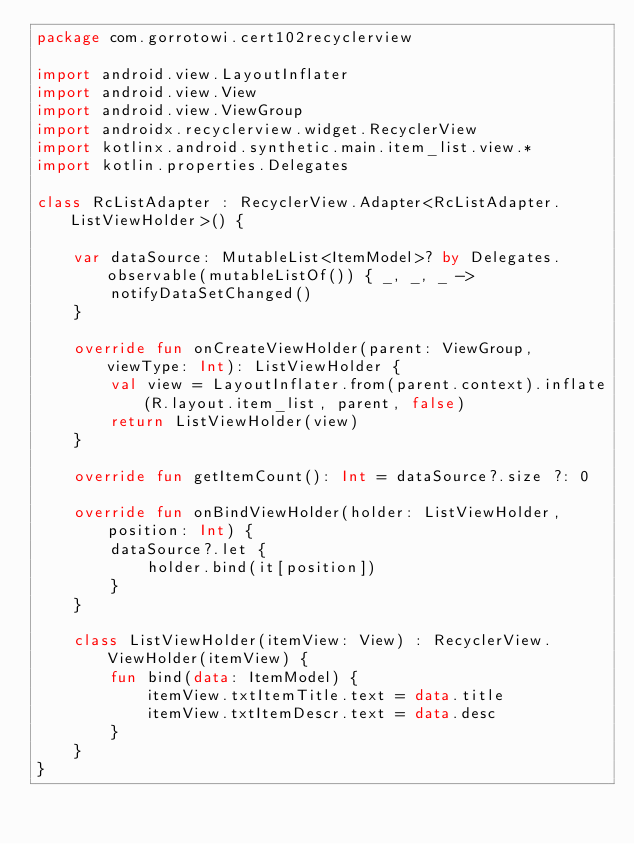Convert code to text. <code><loc_0><loc_0><loc_500><loc_500><_Kotlin_>package com.gorrotowi.cert102recyclerview

import android.view.LayoutInflater
import android.view.View
import android.view.ViewGroup
import androidx.recyclerview.widget.RecyclerView
import kotlinx.android.synthetic.main.item_list.view.*
import kotlin.properties.Delegates

class RcListAdapter : RecyclerView.Adapter<RcListAdapter.ListViewHolder>() {

    var dataSource: MutableList<ItemModel>? by Delegates.observable(mutableListOf()) { _, _, _ ->
        notifyDataSetChanged()
    }

    override fun onCreateViewHolder(parent: ViewGroup, viewType: Int): ListViewHolder {
        val view = LayoutInflater.from(parent.context).inflate(R.layout.item_list, parent, false)
        return ListViewHolder(view)
    }

    override fun getItemCount(): Int = dataSource?.size ?: 0

    override fun onBindViewHolder(holder: ListViewHolder, position: Int) {
        dataSource?.let {
            holder.bind(it[position])
        }
    }

    class ListViewHolder(itemView: View) : RecyclerView.ViewHolder(itemView) {
        fun bind(data: ItemModel) {
            itemView.txtItemTitle.text = data.title
            itemView.txtItemDescr.text = data.desc
        }
    }
}
</code> 